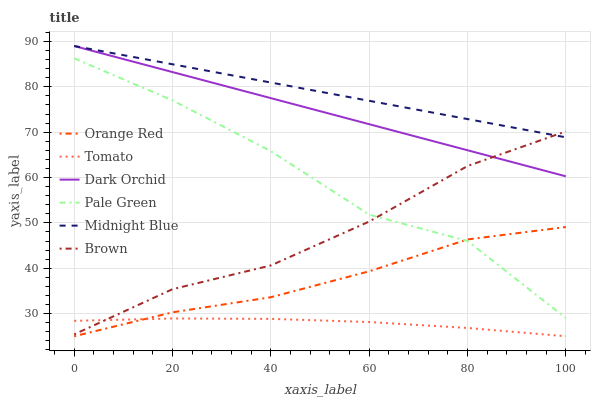Does Tomato have the minimum area under the curve?
Answer yes or no. Yes. Does Midnight Blue have the maximum area under the curve?
Answer yes or no. Yes. Does Brown have the minimum area under the curve?
Answer yes or no. No. Does Brown have the maximum area under the curve?
Answer yes or no. No. Is Dark Orchid the smoothest?
Answer yes or no. Yes. Is Pale Green the roughest?
Answer yes or no. Yes. Is Brown the smoothest?
Answer yes or no. No. Is Brown the roughest?
Answer yes or no. No. Does Tomato have the lowest value?
Answer yes or no. Yes. Does Brown have the lowest value?
Answer yes or no. No. Does Dark Orchid have the highest value?
Answer yes or no. Yes. Does Brown have the highest value?
Answer yes or no. No. Is Tomato less than Midnight Blue?
Answer yes or no. Yes. Is Dark Orchid greater than Orange Red?
Answer yes or no. Yes. Does Tomato intersect Brown?
Answer yes or no. Yes. Is Tomato less than Brown?
Answer yes or no. No. Is Tomato greater than Brown?
Answer yes or no. No. Does Tomato intersect Midnight Blue?
Answer yes or no. No. 